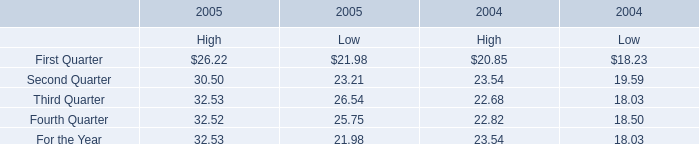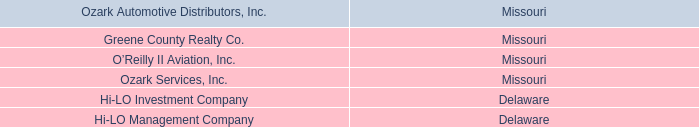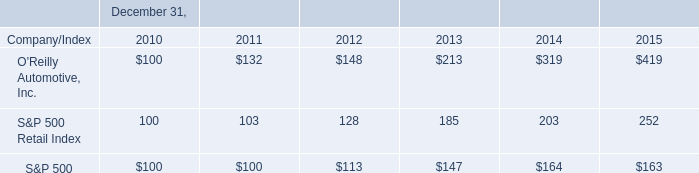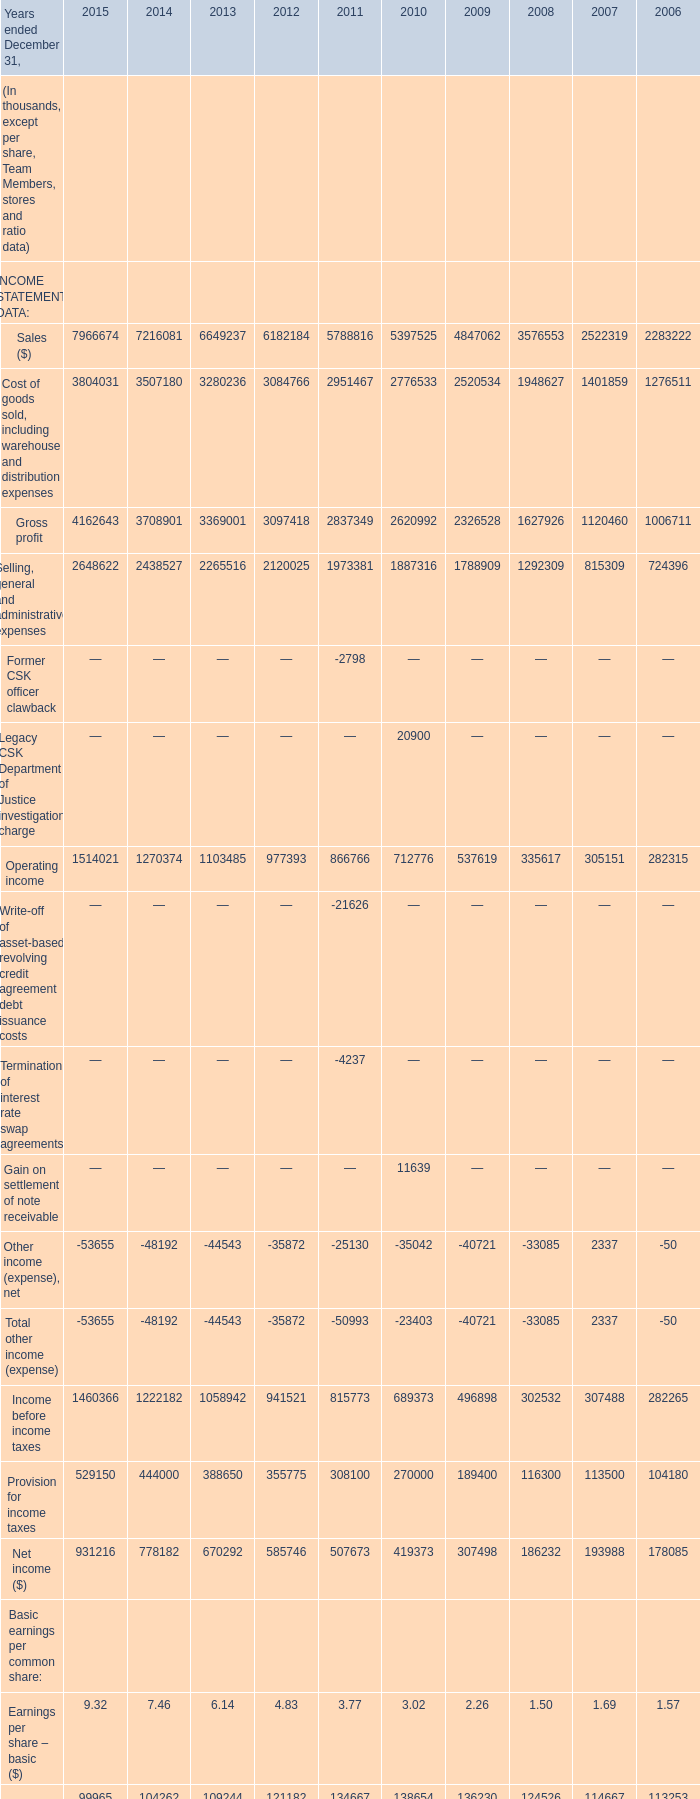What will Earnings per share – basic ($) reach in 2016 if it continues to grow at its current rate? (in thousand) 
Computations: ((((9.32 - 7.46) / 9.32) * 9.32) + 9.32)
Answer: 11.18. 